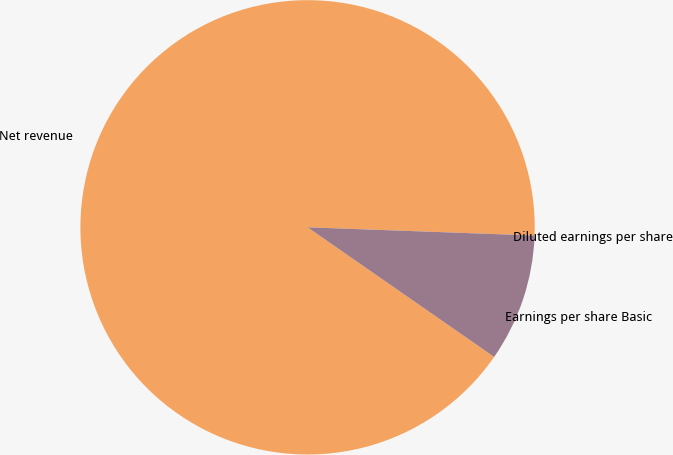<chart> <loc_0><loc_0><loc_500><loc_500><pie_chart><fcel>Net revenue<fcel>Earnings per share Basic<fcel>Diluted earnings per share<nl><fcel>90.91%<fcel>9.09%<fcel>0.0%<nl></chart> 